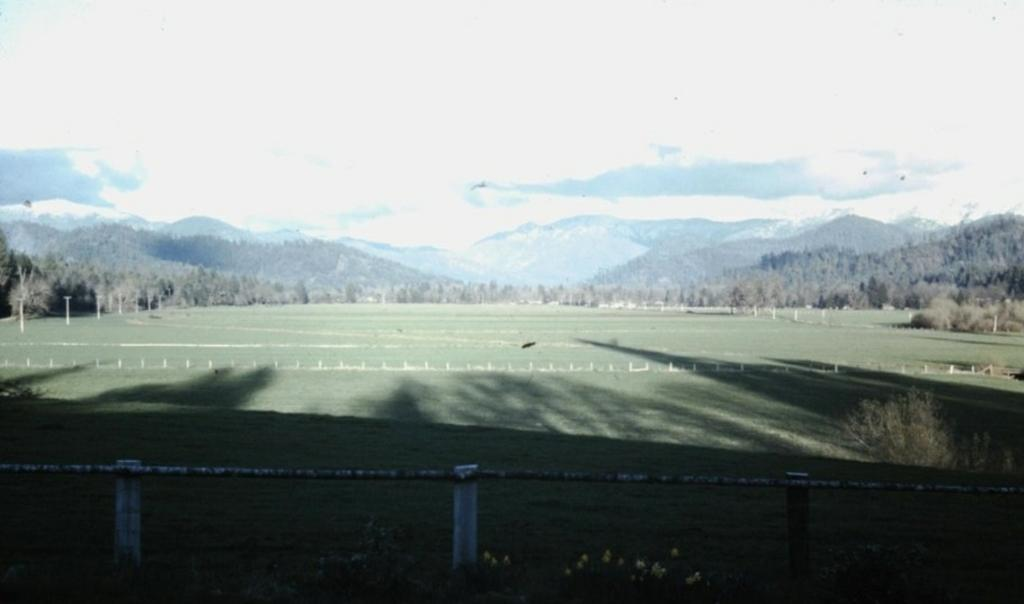What is located at the bottom of the image? There is a fence and grass at the bottom of the image. What type of plants can be seen in the image? There are plants with flowers in the image. What can be seen in the background of the image? Grass, poles, trees, mountains, and clouds are visible in the background of the image. What type of oil can be seen dripping from the flowers in the image? There is no oil present in the image; it features plants with flowers. Can you hear the noise of the uncle in the image? There is no uncle or noise present in the image. 